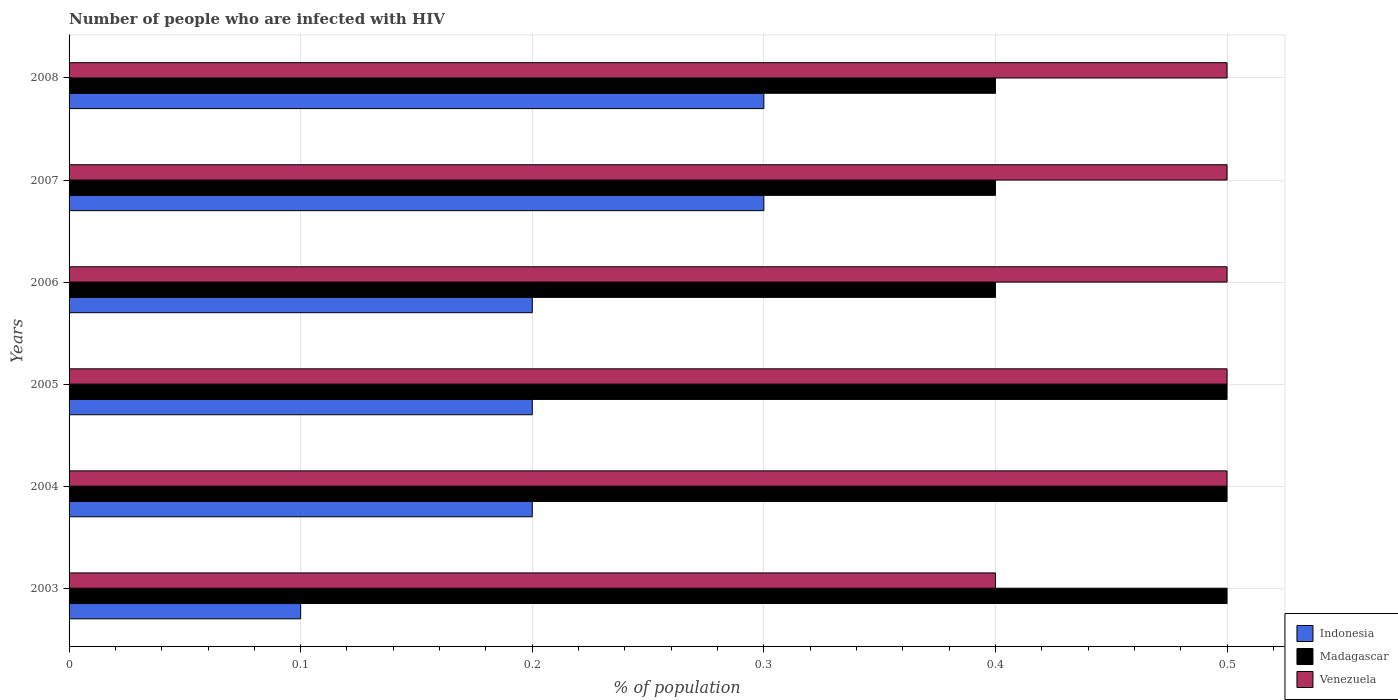How many different coloured bars are there?
Make the answer very short. 3. How many groups of bars are there?
Give a very brief answer. 6. How many bars are there on the 5th tick from the top?
Ensure brevity in your answer.  3. What is the label of the 1st group of bars from the top?
Offer a terse response. 2008. In how many cases, is the number of bars for a given year not equal to the number of legend labels?
Your answer should be very brief. 0. In which year was the percentage of HIV infected population in in Indonesia minimum?
Your answer should be compact. 2003. What is the difference between the percentage of HIV infected population in in Indonesia in 2005 and that in 2007?
Your answer should be compact. -0.1. What is the difference between the percentage of HIV infected population in in Indonesia in 2006 and the percentage of HIV infected population in in Madagascar in 2003?
Provide a short and direct response. -0.3. What is the average percentage of HIV infected population in in Venezuela per year?
Offer a terse response. 0.48. In the year 2007, what is the difference between the percentage of HIV infected population in in Madagascar and percentage of HIV infected population in in Indonesia?
Keep it short and to the point. 0.1. In how many years, is the percentage of HIV infected population in in Venezuela greater than 0.22 %?
Provide a short and direct response. 6. What is the ratio of the percentage of HIV infected population in in Madagascar in 2004 to that in 2005?
Provide a short and direct response. 1. Is the percentage of HIV infected population in in Madagascar in 2005 less than that in 2007?
Provide a short and direct response. No. Is the difference between the percentage of HIV infected population in in Madagascar in 2004 and 2005 greater than the difference between the percentage of HIV infected population in in Indonesia in 2004 and 2005?
Give a very brief answer. No. What is the difference between the highest and the lowest percentage of HIV infected population in in Venezuela?
Offer a very short reply. 0.1. In how many years, is the percentage of HIV infected population in in Venezuela greater than the average percentage of HIV infected population in in Venezuela taken over all years?
Your response must be concise. 5. Is the sum of the percentage of HIV infected population in in Indonesia in 2003 and 2007 greater than the maximum percentage of HIV infected population in in Madagascar across all years?
Make the answer very short. No. What does the 3rd bar from the top in 2003 represents?
Your answer should be compact. Indonesia. What does the 2nd bar from the bottom in 2003 represents?
Give a very brief answer. Madagascar. How many bars are there?
Provide a succinct answer. 18. What is the difference between two consecutive major ticks on the X-axis?
Your answer should be compact. 0.1. Are the values on the major ticks of X-axis written in scientific E-notation?
Offer a terse response. No. Does the graph contain grids?
Ensure brevity in your answer.  Yes. Where does the legend appear in the graph?
Provide a succinct answer. Bottom right. How many legend labels are there?
Keep it short and to the point. 3. How are the legend labels stacked?
Your answer should be very brief. Vertical. What is the title of the graph?
Offer a very short reply. Number of people who are infected with HIV. Does "Middle East & North Africa (all income levels)" appear as one of the legend labels in the graph?
Ensure brevity in your answer.  No. What is the label or title of the X-axis?
Your answer should be very brief. % of population. What is the % of population of Madagascar in 2003?
Provide a short and direct response. 0.5. What is the % of population in Venezuela in 2003?
Ensure brevity in your answer.  0.4. What is the % of population of Madagascar in 2004?
Your answer should be very brief. 0.5. What is the % of population in Indonesia in 2006?
Offer a very short reply. 0.2. What is the % of population of Venezuela in 2006?
Make the answer very short. 0.5. What is the % of population in Indonesia in 2007?
Keep it short and to the point. 0.3. What is the % of population of Madagascar in 2007?
Give a very brief answer. 0.4. What is the % of population of Venezuela in 2008?
Offer a terse response. 0.5. Across all years, what is the maximum % of population of Madagascar?
Offer a very short reply. 0.5. Across all years, what is the minimum % of population in Indonesia?
Offer a terse response. 0.1. Across all years, what is the minimum % of population in Madagascar?
Offer a terse response. 0.4. What is the total % of population of Madagascar in the graph?
Give a very brief answer. 2.7. What is the total % of population in Venezuela in the graph?
Keep it short and to the point. 2.9. What is the difference between the % of population in Indonesia in 2003 and that in 2004?
Your answer should be compact. -0.1. What is the difference between the % of population in Madagascar in 2003 and that in 2004?
Provide a short and direct response. 0. What is the difference between the % of population of Indonesia in 2003 and that in 2005?
Provide a succinct answer. -0.1. What is the difference between the % of population of Indonesia in 2003 and that in 2006?
Provide a succinct answer. -0.1. What is the difference between the % of population of Madagascar in 2003 and that in 2006?
Keep it short and to the point. 0.1. What is the difference between the % of population in Indonesia in 2003 and that in 2008?
Make the answer very short. -0.2. What is the difference between the % of population of Venezuela in 2003 and that in 2008?
Keep it short and to the point. -0.1. What is the difference between the % of population in Madagascar in 2004 and that in 2005?
Offer a very short reply. 0. What is the difference between the % of population of Indonesia in 2004 and that in 2006?
Ensure brevity in your answer.  0. What is the difference between the % of population in Venezuela in 2004 and that in 2006?
Your answer should be very brief. 0. What is the difference between the % of population in Venezuela in 2004 and that in 2007?
Provide a short and direct response. 0. What is the difference between the % of population of Indonesia in 2004 and that in 2008?
Make the answer very short. -0.1. What is the difference between the % of population in Venezuela in 2004 and that in 2008?
Provide a short and direct response. 0. What is the difference between the % of population of Indonesia in 2005 and that in 2006?
Your answer should be compact. 0. What is the difference between the % of population of Venezuela in 2005 and that in 2006?
Your response must be concise. 0. What is the difference between the % of population of Venezuela in 2005 and that in 2007?
Provide a short and direct response. 0. What is the difference between the % of population in Venezuela in 2005 and that in 2008?
Offer a very short reply. 0. What is the difference between the % of population in Indonesia in 2006 and that in 2007?
Keep it short and to the point. -0.1. What is the difference between the % of population in Madagascar in 2006 and that in 2007?
Make the answer very short. 0. What is the difference between the % of population in Indonesia in 2006 and that in 2008?
Your answer should be compact. -0.1. What is the difference between the % of population in Venezuela in 2006 and that in 2008?
Keep it short and to the point. 0. What is the difference between the % of population in Venezuela in 2007 and that in 2008?
Provide a succinct answer. 0. What is the difference between the % of population of Madagascar in 2003 and the % of population of Venezuela in 2004?
Your answer should be very brief. 0. What is the difference between the % of population of Indonesia in 2003 and the % of population of Madagascar in 2005?
Your answer should be compact. -0.4. What is the difference between the % of population in Madagascar in 2003 and the % of population in Venezuela in 2005?
Keep it short and to the point. 0. What is the difference between the % of population of Indonesia in 2003 and the % of population of Venezuela in 2006?
Your answer should be very brief. -0.4. What is the difference between the % of population of Madagascar in 2003 and the % of population of Venezuela in 2006?
Keep it short and to the point. 0. What is the difference between the % of population of Indonesia in 2003 and the % of population of Venezuela in 2007?
Your answer should be compact. -0.4. What is the difference between the % of population of Madagascar in 2003 and the % of population of Venezuela in 2007?
Make the answer very short. 0. What is the difference between the % of population of Indonesia in 2003 and the % of population of Venezuela in 2008?
Offer a very short reply. -0.4. What is the difference between the % of population in Madagascar in 2003 and the % of population in Venezuela in 2008?
Your answer should be very brief. 0. What is the difference between the % of population of Indonesia in 2004 and the % of population of Venezuela in 2007?
Your response must be concise. -0.3. What is the difference between the % of population of Madagascar in 2004 and the % of population of Venezuela in 2007?
Offer a very short reply. 0. What is the difference between the % of population of Indonesia in 2004 and the % of population of Madagascar in 2008?
Give a very brief answer. -0.2. What is the difference between the % of population of Madagascar in 2004 and the % of population of Venezuela in 2008?
Ensure brevity in your answer.  0. What is the difference between the % of population in Indonesia in 2005 and the % of population in Madagascar in 2007?
Offer a very short reply. -0.2. What is the difference between the % of population of Madagascar in 2005 and the % of population of Venezuela in 2007?
Ensure brevity in your answer.  0. What is the difference between the % of population in Indonesia in 2006 and the % of population in Madagascar in 2007?
Provide a succinct answer. -0.2. What is the difference between the % of population in Madagascar in 2006 and the % of population in Venezuela in 2007?
Keep it short and to the point. -0.1. What is the difference between the % of population in Madagascar in 2006 and the % of population in Venezuela in 2008?
Offer a terse response. -0.1. What is the difference between the % of population in Indonesia in 2007 and the % of population in Madagascar in 2008?
Keep it short and to the point. -0.1. What is the difference between the % of population in Indonesia in 2007 and the % of population in Venezuela in 2008?
Offer a very short reply. -0.2. What is the difference between the % of population of Madagascar in 2007 and the % of population of Venezuela in 2008?
Give a very brief answer. -0.1. What is the average % of population in Indonesia per year?
Give a very brief answer. 0.22. What is the average % of population of Madagascar per year?
Make the answer very short. 0.45. What is the average % of population in Venezuela per year?
Ensure brevity in your answer.  0.48. In the year 2003, what is the difference between the % of population in Indonesia and % of population in Madagascar?
Your answer should be very brief. -0.4. In the year 2004, what is the difference between the % of population of Indonesia and % of population of Madagascar?
Your response must be concise. -0.3. In the year 2005, what is the difference between the % of population of Indonesia and % of population of Venezuela?
Keep it short and to the point. -0.3. In the year 2005, what is the difference between the % of population in Madagascar and % of population in Venezuela?
Offer a very short reply. 0. In the year 2006, what is the difference between the % of population of Indonesia and % of population of Madagascar?
Ensure brevity in your answer.  -0.2. In the year 2006, what is the difference between the % of population in Madagascar and % of population in Venezuela?
Your response must be concise. -0.1. In the year 2007, what is the difference between the % of population in Indonesia and % of population in Madagascar?
Your answer should be very brief. -0.1. In the year 2008, what is the difference between the % of population of Indonesia and % of population of Madagascar?
Provide a succinct answer. -0.1. In the year 2008, what is the difference between the % of population of Indonesia and % of population of Venezuela?
Ensure brevity in your answer.  -0.2. In the year 2008, what is the difference between the % of population in Madagascar and % of population in Venezuela?
Your answer should be very brief. -0.1. What is the ratio of the % of population in Madagascar in 2003 to that in 2004?
Provide a succinct answer. 1. What is the ratio of the % of population of Venezuela in 2003 to that in 2004?
Provide a succinct answer. 0.8. What is the ratio of the % of population in Indonesia in 2003 to that in 2005?
Your response must be concise. 0.5. What is the ratio of the % of population in Madagascar in 2003 to that in 2005?
Ensure brevity in your answer.  1. What is the ratio of the % of population in Madagascar in 2003 to that in 2006?
Ensure brevity in your answer.  1.25. What is the ratio of the % of population in Madagascar in 2003 to that in 2008?
Offer a terse response. 1.25. What is the ratio of the % of population of Indonesia in 2004 to that in 2005?
Give a very brief answer. 1. What is the ratio of the % of population of Madagascar in 2004 to that in 2005?
Offer a terse response. 1. What is the ratio of the % of population in Venezuela in 2004 to that in 2005?
Keep it short and to the point. 1. What is the ratio of the % of population of Madagascar in 2004 to that in 2006?
Provide a short and direct response. 1.25. What is the ratio of the % of population in Indonesia in 2004 to that in 2007?
Give a very brief answer. 0.67. What is the ratio of the % of population of Madagascar in 2004 to that in 2007?
Your answer should be very brief. 1.25. What is the ratio of the % of population of Venezuela in 2004 to that in 2007?
Ensure brevity in your answer.  1. What is the ratio of the % of population in Indonesia in 2004 to that in 2008?
Provide a succinct answer. 0.67. What is the ratio of the % of population of Venezuela in 2004 to that in 2008?
Offer a very short reply. 1. What is the ratio of the % of population in Indonesia in 2005 to that in 2006?
Provide a succinct answer. 1. What is the ratio of the % of population in Madagascar in 2005 to that in 2006?
Offer a terse response. 1.25. What is the ratio of the % of population of Madagascar in 2005 to that in 2007?
Provide a succinct answer. 1.25. What is the ratio of the % of population of Indonesia in 2005 to that in 2008?
Offer a terse response. 0.67. What is the ratio of the % of population of Madagascar in 2006 to that in 2007?
Your response must be concise. 1. What is the ratio of the % of population in Venezuela in 2006 to that in 2007?
Your answer should be very brief. 1. What is the ratio of the % of population in Madagascar in 2006 to that in 2008?
Give a very brief answer. 1. What is the ratio of the % of population in Venezuela in 2006 to that in 2008?
Give a very brief answer. 1. What is the difference between the highest and the second highest % of population of Indonesia?
Provide a short and direct response. 0. What is the difference between the highest and the lowest % of population of Indonesia?
Your answer should be compact. 0.2. 